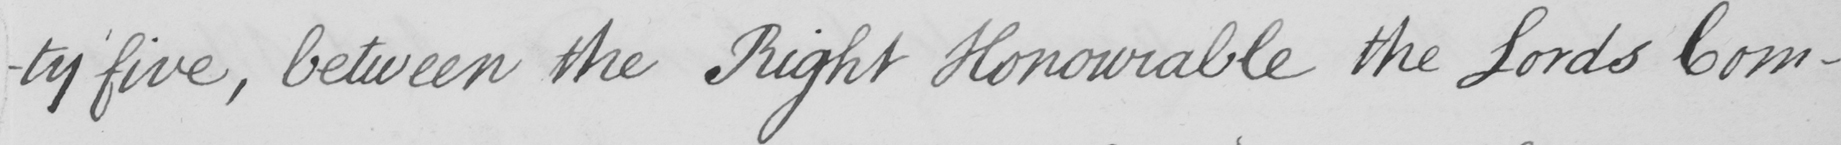What text is written in this handwritten line? -ty five , between the Right Honourable the Lords Com- 